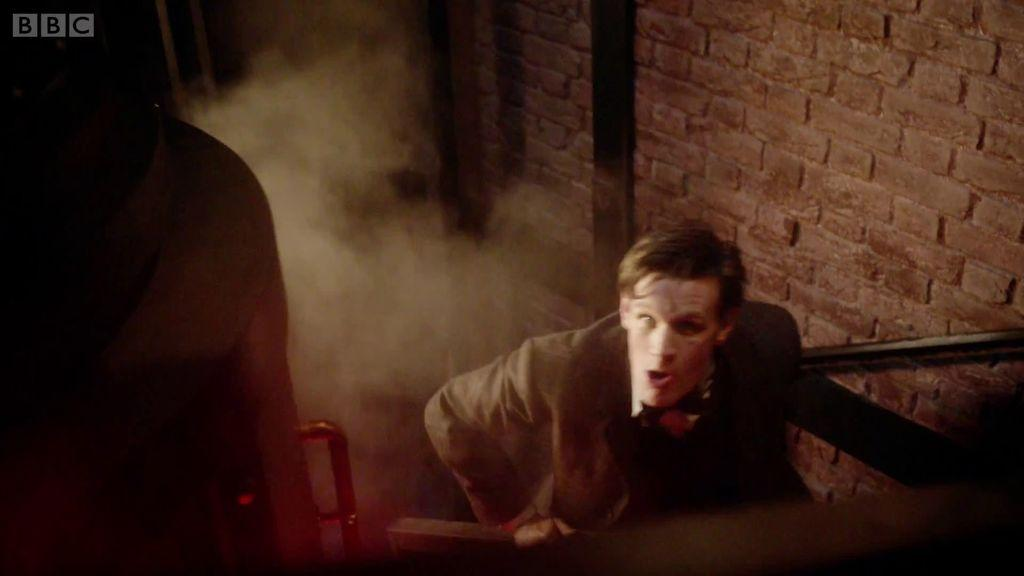Where was the image taken? The image was taken indoors. What can be seen in the background of the image? There is a brick wall in the background of the image. What is the man in the image doing? The man is climbing the stairs on the right side of the image. What safety feature is associated with the stairs? There is a railing associated with the stairs. How many eggs are being carried by the man in the image? There are no eggs visible in the image; the man is climbing the stairs without carrying any eggs. 